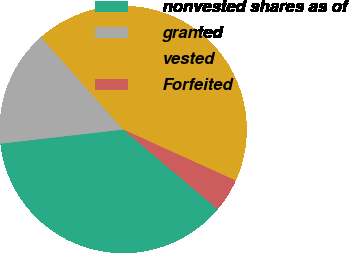<chart> <loc_0><loc_0><loc_500><loc_500><pie_chart><fcel>nonvested shares as of<fcel>granted<fcel>vested<fcel>Forfeited<nl><fcel>37.04%<fcel>15.25%<fcel>43.36%<fcel>4.36%<nl></chart> 